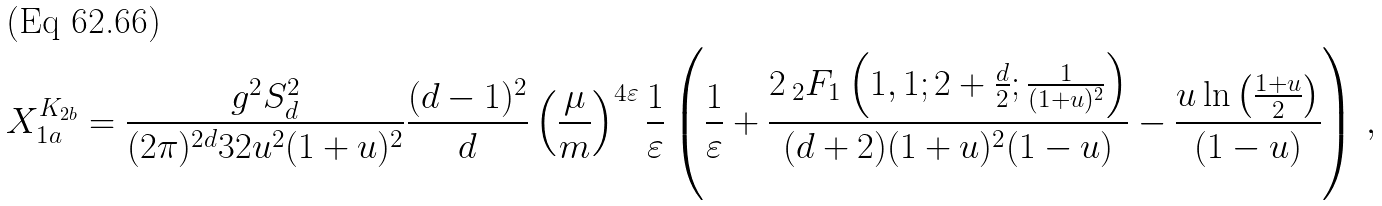Convert formula to latex. <formula><loc_0><loc_0><loc_500><loc_500>X ^ { K _ { 2 b } } _ { 1 a } = \frac { g ^ { 2 } S _ { d } ^ { 2 } } { ( 2 \pi ) ^ { 2 d } 3 2 u ^ { 2 } ( 1 + u ) ^ { 2 } } \frac { ( d - 1 ) ^ { 2 } } { d } \left ( \frac { \mu } { m } \right ) ^ { 4 \varepsilon } \frac { 1 } { \varepsilon } \left ( \frac { 1 } { \varepsilon } + \frac { 2 \, { _ { 2 } F _ { 1 } } \left ( 1 , 1 ; 2 + \frac { d } { 2 } ; \frac { 1 } { ( 1 + u ) ^ { 2 } } \right ) } { ( d + 2 ) ( 1 + u ) ^ { 2 } ( 1 - u ) } - \frac { u \ln \left ( \frac { 1 + u } { 2 } \right ) } { ( 1 - u ) } \right ) \, ,</formula> 